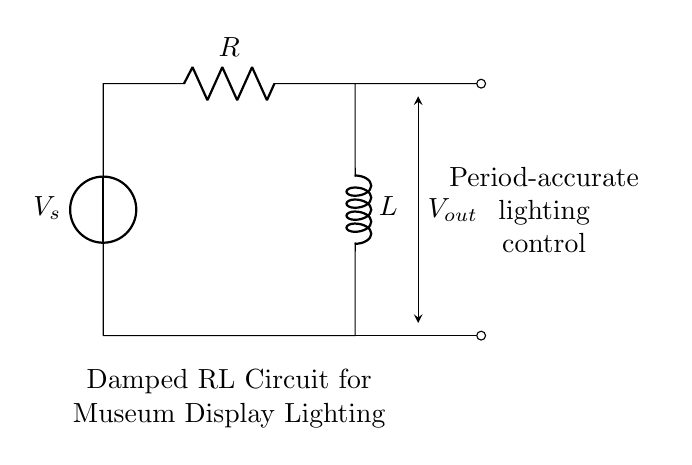What type of components are used in this circuit? The circuit includes a voltage source, a resistor, and an inductor. These are the primary components depicted.
Answer: voltage source, resistor, inductor What is the function of the resistor in this circuit? The resistor limits the current flow, providing control over how quickly the inductor charges and discharges, which affects the dampening.
Answer: current limiting How does the inductor affect the circuit's behavior? The inductor stores energy in a magnetic field when current flows, making the circuit oscillate and subsequently dampen over time.
Answer: stores energy What indicates that this is a damped RL circuit? The presence of the resistor alongside the inductor signifies that it is a damped RL circuit because the resistor introduces resistance that dampens oscillations.
Answer: presence of a resistor What is the purpose of output voltage in this circuit? The output voltage reflects the voltage drop across the circuit, which is important for controlling the light intensity in museum displays.
Answer: lighting control How is the output voltage connected in the circuit? The output voltage is taken between the connections of the resistor and inductor, indicating where to measure the voltage across these components.
Answer: across R and L 